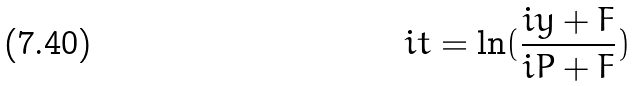Convert formula to latex. <formula><loc_0><loc_0><loc_500><loc_500>i t = \ln ( \frac { i y + F } { i P + F } )</formula> 